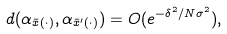<formula> <loc_0><loc_0><loc_500><loc_500>d ( \alpha _ { \bar { x } ( \cdot ) } , \alpha _ { \bar { x } ^ { \prime } ( \cdot ) } ) = O ( e ^ { - \delta ^ { 2 } / N \sigma ^ { 2 } } ) ,</formula> 